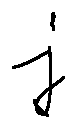Convert formula to latex. <formula><loc_0><loc_0><loc_500><loc_500>j</formula> 